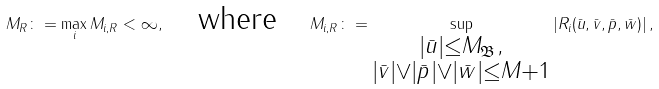Convert formula to latex. <formula><loc_0><loc_0><loc_500><loc_500>M _ { R } \colon = \max _ { i } M _ { i , R } < \infty , \quad \text {where} \quad M _ { i , R } \colon = \sup _ { \substack { | \bar { u } | \leq M _ { \mathfrak B } , \\ | \bar { v } | \vee | \bar { p } | \vee | \bar { w } | \leq M + 1 } } \left | R _ { i } ( \bar { u } , \bar { v } , \bar { p } , \bar { w } ) \right | ,</formula> 